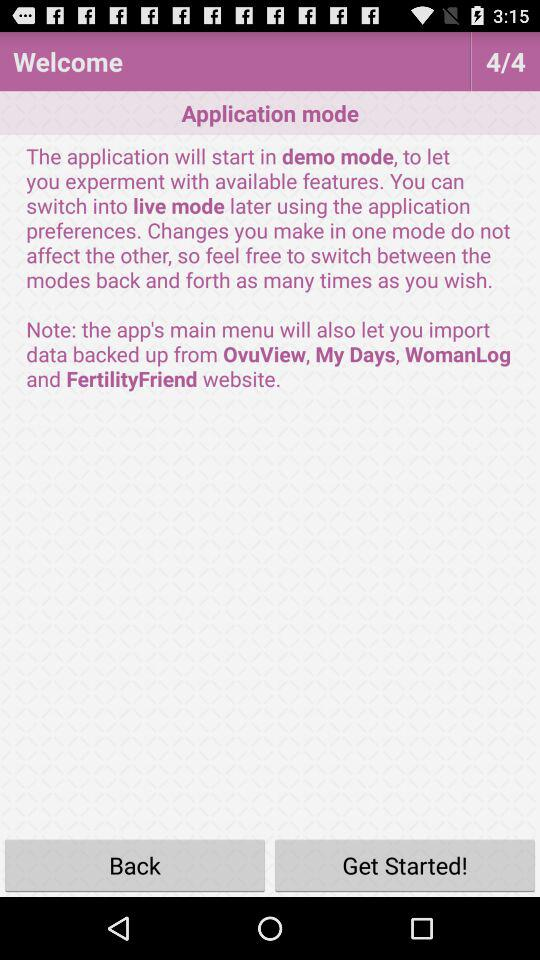At what page am I? You are on page 4. 